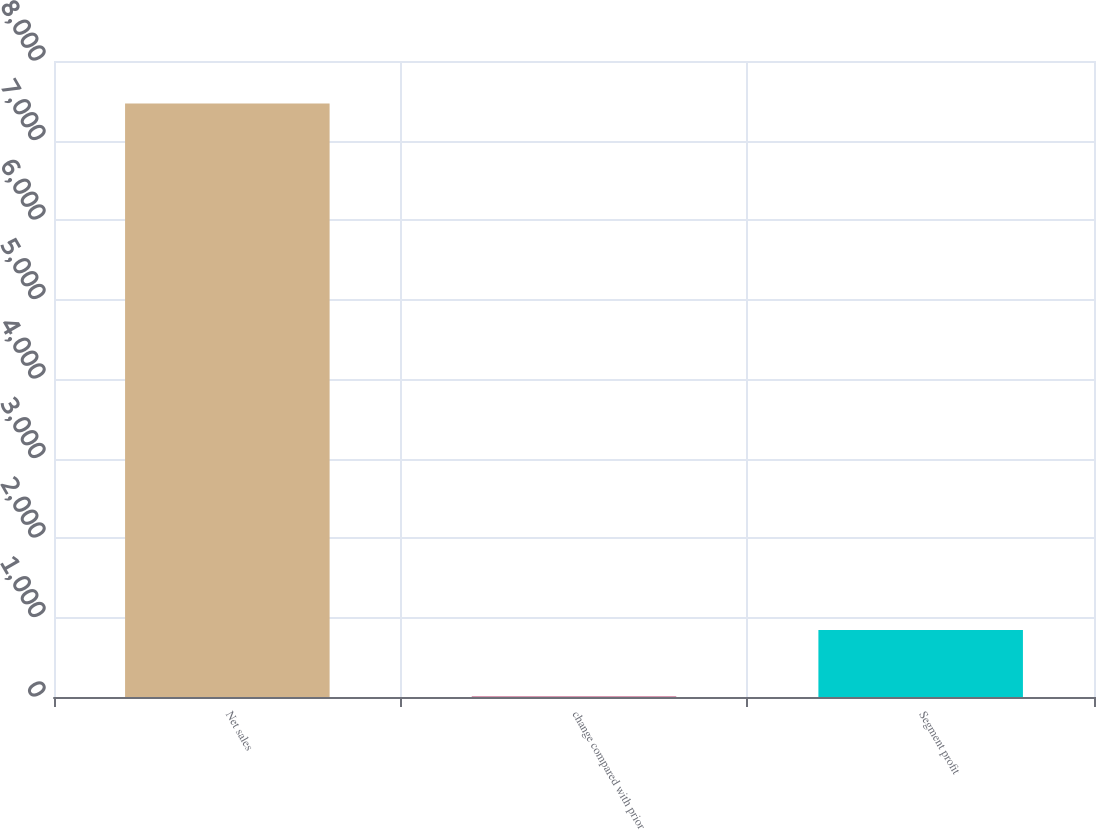Convert chart. <chart><loc_0><loc_0><loc_500><loc_500><bar_chart><fcel>Net sales<fcel>change compared with prior<fcel>Segment profit<nl><fcel>7464<fcel>7<fcel>843<nl></chart> 